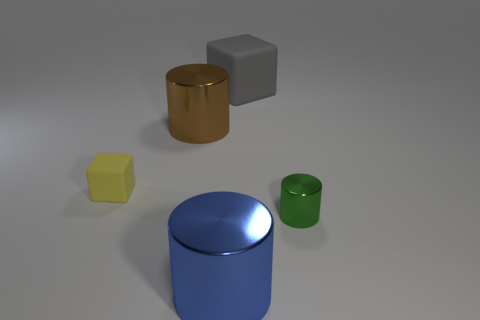Add 3 green shiny cylinders. How many objects exist? 8 Subtract all blocks. How many objects are left? 3 Subtract 0 brown cubes. How many objects are left? 5 Subtract all blue things. Subtract all blue objects. How many objects are left? 3 Add 4 cubes. How many cubes are left? 6 Add 4 cubes. How many cubes exist? 6 